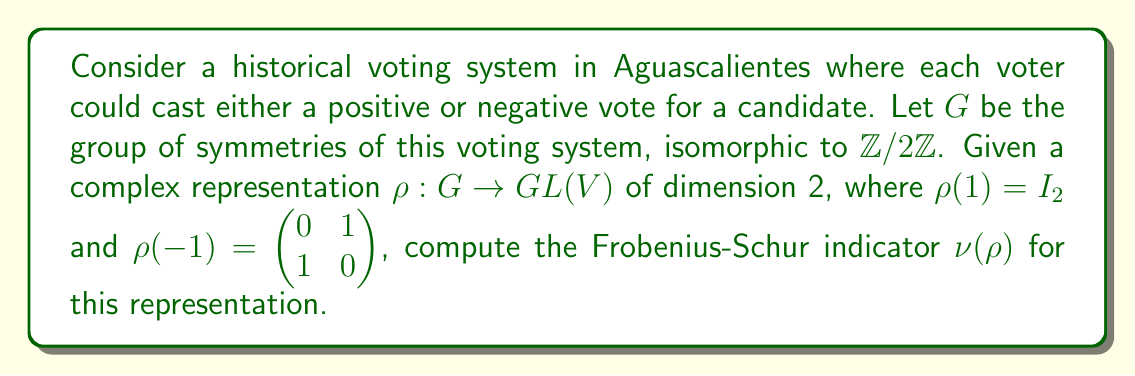Can you answer this question? To compute the Frobenius-Schur indicator $\nu(\rho)$ for the given representation, we'll follow these steps:

1) The Frobenius-Schur indicator is defined as:

   $$\nu(\rho) = \frac{1}{|G|} \sum_{g \in G} \chi_\rho(g^2)$$

   where $\chi_\rho$ is the character of the representation $\rho$.

2) In our case, $|G| = 2$ since $G \cong \mathbb{Z}/2\mathbb{Z}$.

3) We need to compute $\chi_\rho(g^2)$ for each $g \in G$:

   For $g = 1$: $\chi_\rho(1^2) = \chi_\rho(1) = \text{Tr}(I_2) = 2$

   For $g = -1$: $\chi_\rho((-1)^2) = \chi_\rho(1) = \text{Tr}(I_2) = 2$

4) Now we can compute the sum:

   $$\sum_{g \in G} \chi_\rho(g^2) = \chi_\rho(1^2) + \chi_\rho((-1)^2) = 2 + 2 = 4$$

5) Finally, we calculate the Frobenius-Schur indicator:

   $$\nu(\rho) = \frac{1}{|G|} \sum_{g \in G} \chi_\rho(g^2) = \frac{1}{2} \cdot 4 = 2$$

The Frobenius-Schur indicator being 2 indicates that this representation is the direct sum of two copies of the trivial representation.
Answer: $\nu(\rho) = 2$ 